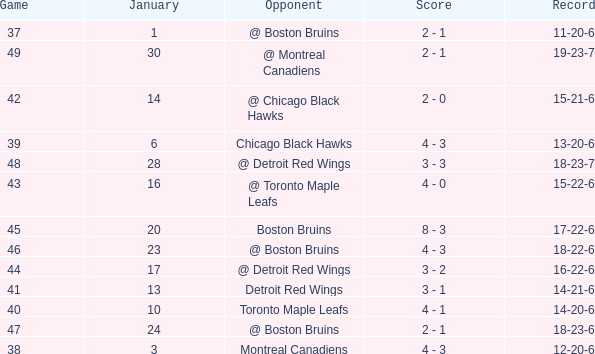What day in January was the game greater than 49 and had @ Montreal Canadiens as opponents? None. 